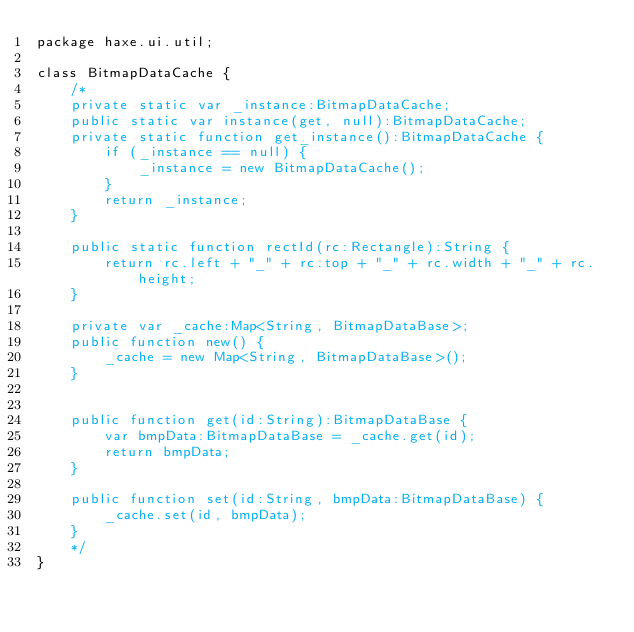<code> <loc_0><loc_0><loc_500><loc_500><_Haxe_>package haxe.ui.util;

class BitmapDataCache {
    /*
    private static var _instance:BitmapDataCache;
    public static var instance(get, null):BitmapDataCache;
    private static function get_instance():BitmapDataCache {
        if (_instance == null) {
            _instance = new BitmapDataCache();
        }
        return _instance;
    }

    public static function rectId(rc:Rectangle):String {
        return rc.left + "_" + rc.top + "_" + rc.width + "_" + rc.height;
    }

    private var _cache:Map<String, BitmapDataBase>;
    public function new() {
        _cache = new Map<String, BitmapDataBase>();
    }


    public function get(id:String):BitmapDataBase {
        var bmpData:BitmapDataBase = _cache.get(id);
        return bmpData;
    }

    public function set(id:String, bmpData:BitmapDataBase) {
        _cache.set(id, bmpData);
    }
    */
}</code> 